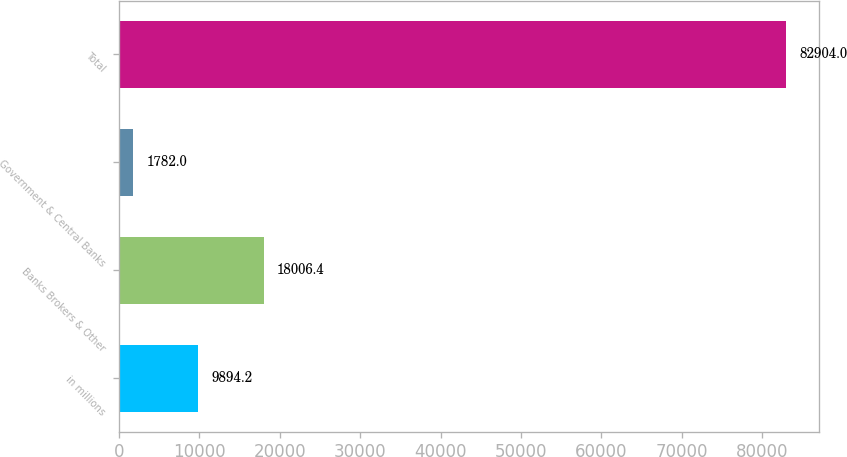Convert chart to OTSL. <chart><loc_0><loc_0><loc_500><loc_500><bar_chart><fcel>in millions<fcel>Banks Brokers & Other<fcel>Government & Central Banks<fcel>Total<nl><fcel>9894.2<fcel>18006.4<fcel>1782<fcel>82904<nl></chart> 